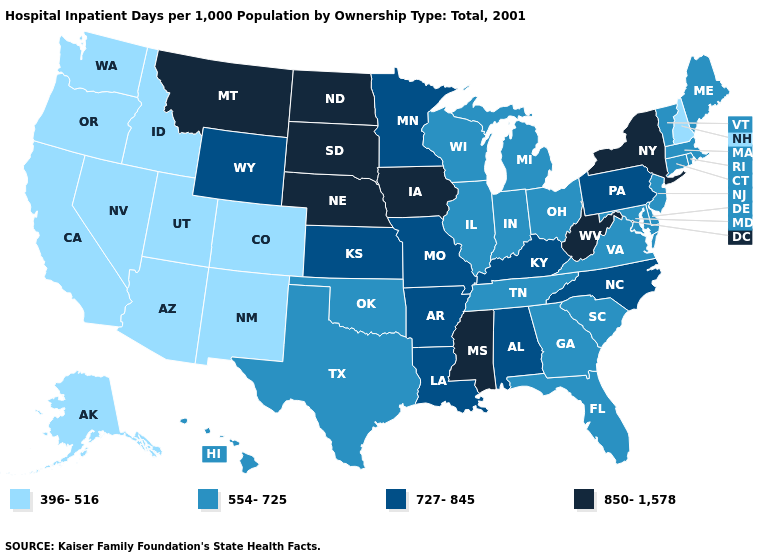Does Georgia have the same value as New Jersey?
Concise answer only. Yes. Does North Dakota have the highest value in the MidWest?
Quick response, please. Yes. Does New York have the lowest value in the Northeast?
Answer briefly. No. What is the value of Oklahoma?
Concise answer only. 554-725. Name the states that have a value in the range 554-725?
Keep it brief. Connecticut, Delaware, Florida, Georgia, Hawaii, Illinois, Indiana, Maine, Maryland, Massachusetts, Michigan, New Jersey, Ohio, Oklahoma, Rhode Island, South Carolina, Tennessee, Texas, Vermont, Virginia, Wisconsin. What is the value of Arkansas?
Concise answer only. 727-845. What is the value of Illinois?
Be succinct. 554-725. Name the states that have a value in the range 396-516?
Answer briefly. Alaska, Arizona, California, Colorado, Idaho, Nevada, New Hampshire, New Mexico, Oregon, Utah, Washington. What is the value of North Dakota?
Answer briefly. 850-1,578. Does New Jersey have a higher value than Indiana?
Answer briefly. No. What is the value of Kentucky?
Answer briefly. 727-845. Which states have the lowest value in the MidWest?
Answer briefly. Illinois, Indiana, Michigan, Ohio, Wisconsin. Does Illinois have a lower value than Kentucky?
Answer briefly. Yes. Does New Hampshire have the lowest value in the Northeast?
Short answer required. Yes. 